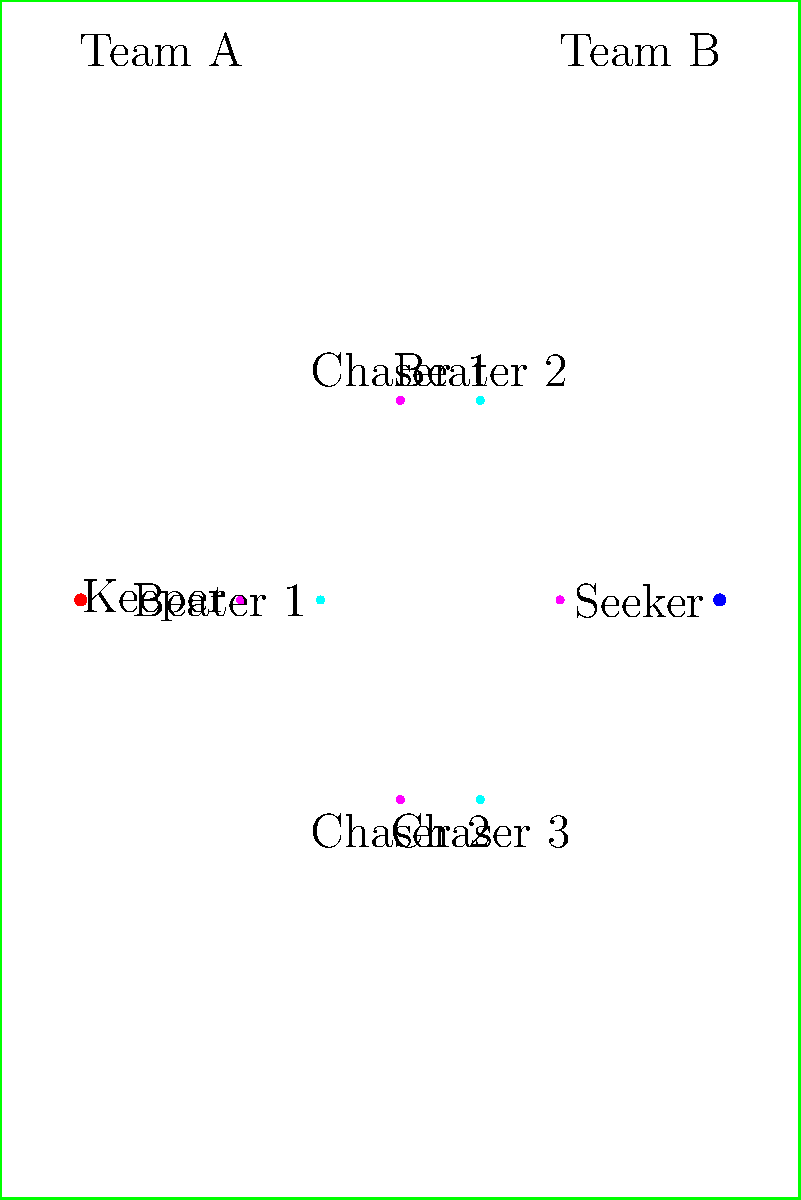In the given Quidditch field layout, Team A (magenta) is employing a defensive strategy known as the "Double Eight Loop." Which player's position is crucial for initiating this maneuver, and what is the primary purpose of this strategy? To answer this question, let's break down the key elements of the "Double Eight Loop" strategy:

1. The "Double Eight Loop" is a defensive maneuver primarily executed by the Keeper.

2. In the diagram, we can identify the Keeper as the magenta dot positioned at (30,75), labeled "Keeper" on the left side of the field.

3. The strategy involves the Keeper flying in a figure-eight pattern around the goal hoops.

4. The purpose of this maneuver is twofold:
   a) It allows the Keeper to cover all three goal hoops effectively.
   b) It confuses opposing Chasers, making it harder for them to score.

5. The Keeper's position is crucial because:
   a) They are closest to the goal posts (red dot at (10,75)).
   b) They have the best vantage point to see incoming Chasers and the Quaffle.

6. The primary purpose of this strategy is to enhance goal protection by creating a dynamic and unpredictable defensive pattern.

Therefore, the Keeper's position is crucial for initiating the "Double Eight Loop," and its primary purpose is to improve goal defense through confusion and better coverage of the scoring area.
Answer: Keeper; enhance goal protection 